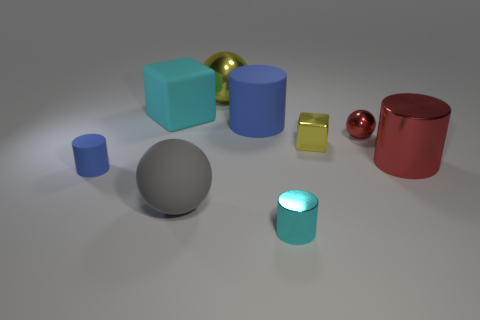Add 1 cyan matte blocks. How many objects exist? 10 Subtract all cylinders. How many objects are left? 5 Subtract 0 purple cylinders. How many objects are left? 9 Subtract all big yellow objects. Subtract all cyan metallic things. How many objects are left? 7 Add 2 tiny red balls. How many tiny red balls are left? 3 Add 6 large cyan cubes. How many large cyan cubes exist? 7 